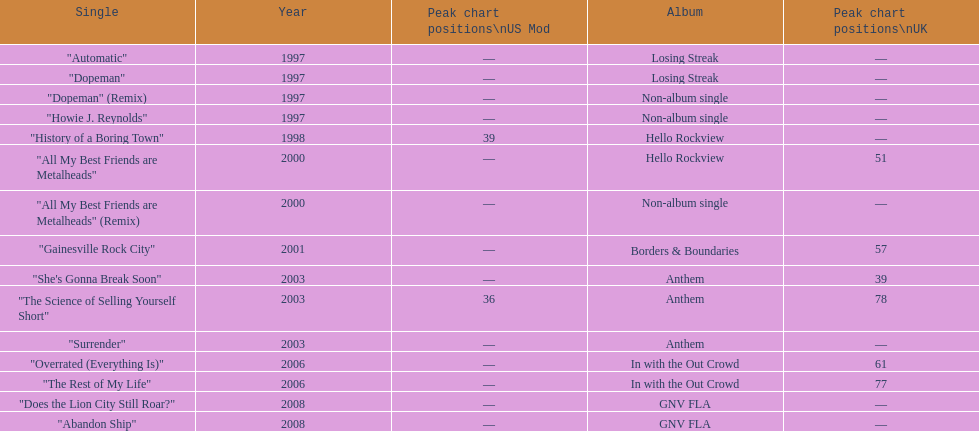Help me parse the entirety of this table. {'header': ['Single', 'Year', 'Peak chart positions\\nUS Mod', 'Album', 'Peak chart positions\\nUK'], 'rows': [['"Automatic"', '1997', '—', 'Losing Streak', '—'], ['"Dopeman"', '1997', '—', 'Losing Streak', '—'], ['"Dopeman" (Remix)', '1997', '—', 'Non-album single', '—'], ['"Howie J. Reynolds"', '1997', '—', 'Non-album single', '—'], ['"History of a Boring Town"', '1998', '39', 'Hello Rockview', '—'], ['"All My Best Friends are Metalheads"', '2000', '—', 'Hello Rockview', '51'], ['"All My Best Friends are Metalheads" (Remix)', '2000', '—', 'Non-album single', '—'], ['"Gainesville Rock City"', '2001', '—', 'Borders & Boundaries', '57'], ['"She\'s Gonna Break Soon"', '2003', '—', 'Anthem', '39'], ['"The Science of Selling Yourself Short"', '2003', '36', 'Anthem', '78'], ['"Surrender"', '2003', '—', 'Anthem', '—'], ['"Overrated (Everything Is)"', '2006', '—', 'In with the Out Crowd', '61'], ['"The Rest of My Life"', '2006', '—', 'In with the Out Crowd', '77'], ['"Does the Lion City Still Roar?"', '2008', '—', 'GNV FLA', '—'], ['"Abandon Ship"', '2008', '—', 'GNV FLA', '—']]} Over how many years did the gap between the losing streak album and gnv fla occur? 11. 